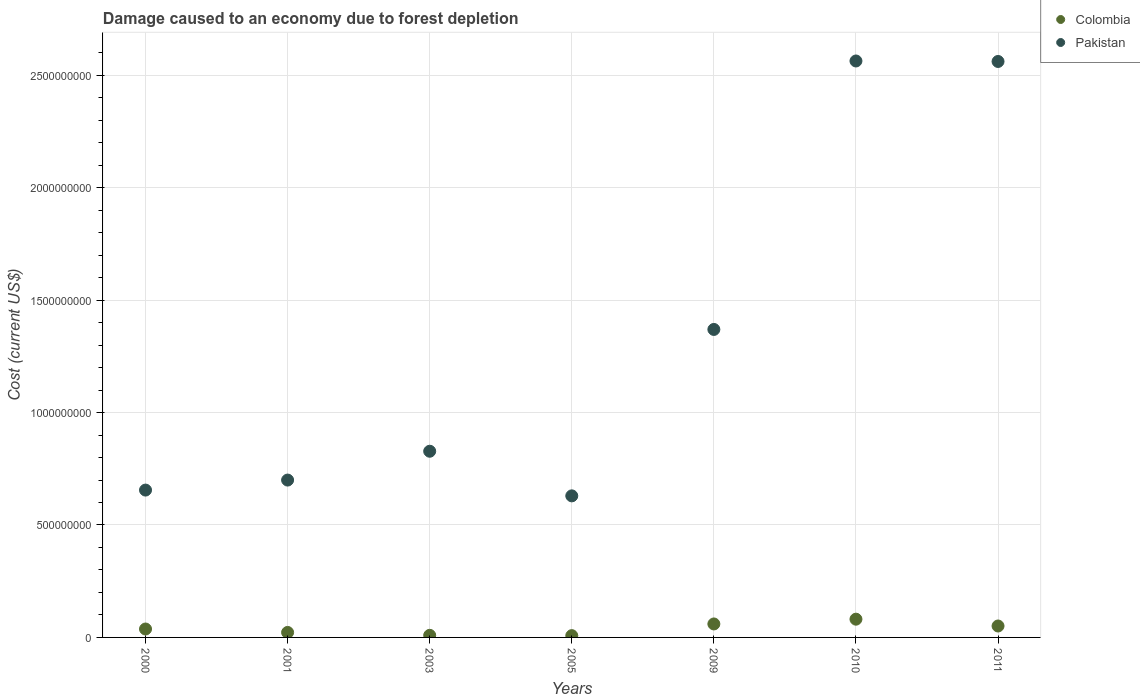What is the cost of damage caused due to forest depletion in Colombia in 2000?
Your answer should be very brief. 3.74e+07. Across all years, what is the maximum cost of damage caused due to forest depletion in Pakistan?
Give a very brief answer. 2.56e+09. Across all years, what is the minimum cost of damage caused due to forest depletion in Pakistan?
Provide a short and direct response. 6.30e+08. In which year was the cost of damage caused due to forest depletion in Pakistan minimum?
Give a very brief answer. 2005. What is the total cost of damage caused due to forest depletion in Colombia in the graph?
Provide a short and direct response. 2.69e+08. What is the difference between the cost of damage caused due to forest depletion in Pakistan in 2003 and that in 2010?
Make the answer very short. -1.74e+09. What is the difference between the cost of damage caused due to forest depletion in Colombia in 2003 and the cost of damage caused due to forest depletion in Pakistan in 2001?
Your answer should be compact. -6.91e+08. What is the average cost of damage caused due to forest depletion in Pakistan per year?
Offer a terse response. 1.33e+09. In the year 2003, what is the difference between the cost of damage caused due to forest depletion in Pakistan and cost of damage caused due to forest depletion in Colombia?
Keep it short and to the point. 8.19e+08. What is the ratio of the cost of damage caused due to forest depletion in Pakistan in 2001 to that in 2003?
Provide a succinct answer. 0.85. Is the cost of damage caused due to forest depletion in Pakistan in 2005 less than that in 2011?
Keep it short and to the point. Yes. What is the difference between the highest and the second highest cost of damage caused due to forest depletion in Colombia?
Keep it short and to the point. 2.12e+07. What is the difference between the highest and the lowest cost of damage caused due to forest depletion in Pakistan?
Give a very brief answer. 1.93e+09. Does the cost of damage caused due to forest depletion in Colombia monotonically increase over the years?
Offer a very short reply. No. Is the cost of damage caused due to forest depletion in Colombia strictly greater than the cost of damage caused due to forest depletion in Pakistan over the years?
Your answer should be very brief. No. Is the cost of damage caused due to forest depletion in Colombia strictly less than the cost of damage caused due to forest depletion in Pakistan over the years?
Your answer should be very brief. Yes. How many years are there in the graph?
Give a very brief answer. 7. What is the difference between two consecutive major ticks on the Y-axis?
Ensure brevity in your answer.  5.00e+08. Does the graph contain any zero values?
Provide a succinct answer. No. Does the graph contain grids?
Ensure brevity in your answer.  Yes. Where does the legend appear in the graph?
Your answer should be compact. Top right. How are the legend labels stacked?
Provide a succinct answer. Vertical. What is the title of the graph?
Offer a very short reply. Damage caused to an economy due to forest depletion. Does "Korea (Democratic)" appear as one of the legend labels in the graph?
Ensure brevity in your answer.  No. What is the label or title of the X-axis?
Provide a succinct answer. Years. What is the label or title of the Y-axis?
Your response must be concise. Cost (current US$). What is the Cost (current US$) in Colombia in 2000?
Provide a short and direct response. 3.74e+07. What is the Cost (current US$) in Pakistan in 2000?
Your response must be concise. 6.55e+08. What is the Cost (current US$) of Colombia in 2001?
Give a very brief answer. 2.22e+07. What is the Cost (current US$) of Pakistan in 2001?
Offer a very short reply. 7.00e+08. What is the Cost (current US$) in Colombia in 2003?
Give a very brief answer. 9.33e+06. What is the Cost (current US$) in Pakistan in 2003?
Your answer should be compact. 8.28e+08. What is the Cost (current US$) of Colombia in 2005?
Give a very brief answer. 7.93e+06. What is the Cost (current US$) in Pakistan in 2005?
Your answer should be very brief. 6.30e+08. What is the Cost (current US$) in Colombia in 2009?
Give a very brief answer. 5.99e+07. What is the Cost (current US$) in Pakistan in 2009?
Your answer should be compact. 1.37e+09. What is the Cost (current US$) of Colombia in 2010?
Offer a very short reply. 8.12e+07. What is the Cost (current US$) in Pakistan in 2010?
Provide a succinct answer. 2.56e+09. What is the Cost (current US$) of Colombia in 2011?
Offer a terse response. 5.09e+07. What is the Cost (current US$) of Pakistan in 2011?
Provide a succinct answer. 2.56e+09. Across all years, what is the maximum Cost (current US$) of Colombia?
Give a very brief answer. 8.12e+07. Across all years, what is the maximum Cost (current US$) of Pakistan?
Offer a very short reply. 2.56e+09. Across all years, what is the minimum Cost (current US$) in Colombia?
Offer a terse response. 7.93e+06. Across all years, what is the minimum Cost (current US$) in Pakistan?
Keep it short and to the point. 6.30e+08. What is the total Cost (current US$) of Colombia in the graph?
Give a very brief answer. 2.69e+08. What is the total Cost (current US$) in Pakistan in the graph?
Make the answer very short. 9.31e+09. What is the difference between the Cost (current US$) in Colombia in 2000 and that in 2001?
Provide a succinct answer. 1.52e+07. What is the difference between the Cost (current US$) in Pakistan in 2000 and that in 2001?
Ensure brevity in your answer.  -4.45e+07. What is the difference between the Cost (current US$) of Colombia in 2000 and that in 2003?
Your answer should be very brief. 2.81e+07. What is the difference between the Cost (current US$) in Pakistan in 2000 and that in 2003?
Provide a short and direct response. -1.73e+08. What is the difference between the Cost (current US$) in Colombia in 2000 and that in 2005?
Offer a terse response. 2.95e+07. What is the difference between the Cost (current US$) of Pakistan in 2000 and that in 2005?
Ensure brevity in your answer.  2.57e+07. What is the difference between the Cost (current US$) of Colombia in 2000 and that in 2009?
Make the answer very short. -2.25e+07. What is the difference between the Cost (current US$) in Pakistan in 2000 and that in 2009?
Make the answer very short. -7.14e+08. What is the difference between the Cost (current US$) in Colombia in 2000 and that in 2010?
Make the answer very short. -4.37e+07. What is the difference between the Cost (current US$) in Pakistan in 2000 and that in 2010?
Keep it short and to the point. -1.91e+09. What is the difference between the Cost (current US$) of Colombia in 2000 and that in 2011?
Your response must be concise. -1.34e+07. What is the difference between the Cost (current US$) in Pakistan in 2000 and that in 2011?
Ensure brevity in your answer.  -1.91e+09. What is the difference between the Cost (current US$) in Colombia in 2001 and that in 2003?
Your answer should be very brief. 1.29e+07. What is the difference between the Cost (current US$) of Pakistan in 2001 and that in 2003?
Your answer should be compact. -1.28e+08. What is the difference between the Cost (current US$) in Colombia in 2001 and that in 2005?
Give a very brief answer. 1.43e+07. What is the difference between the Cost (current US$) in Pakistan in 2001 and that in 2005?
Your answer should be compact. 7.03e+07. What is the difference between the Cost (current US$) in Colombia in 2001 and that in 2009?
Your answer should be compact. -3.77e+07. What is the difference between the Cost (current US$) of Pakistan in 2001 and that in 2009?
Your response must be concise. -6.70e+08. What is the difference between the Cost (current US$) in Colombia in 2001 and that in 2010?
Give a very brief answer. -5.89e+07. What is the difference between the Cost (current US$) in Pakistan in 2001 and that in 2010?
Keep it short and to the point. -1.86e+09. What is the difference between the Cost (current US$) in Colombia in 2001 and that in 2011?
Ensure brevity in your answer.  -2.86e+07. What is the difference between the Cost (current US$) in Pakistan in 2001 and that in 2011?
Make the answer very short. -1.86e+09. What is the difference between the Cost (current US$) in Colombia in 2003 and that in 2005?
Your response must be concise. 1.39e+06. What is the difference between the Cost (current US$) in Pakistan in 2003 and that in 2005?
Ensure brevity in your answer.  1.98e+08. What is the difference between the Cost (current US$) of Colombia in 2003 and that in 2009?
Give a very brief answer. -5.06e+07. What is the difference between the Cost (current US$) in Pakistan in 2003 and that in 2009?
Provide a short and direct response. -5.42e+08. What is the difference between the Cost (current US$) of Colombia in 2003 and that in 2010?
Provide a short and direct response. -7.18e+07. What is the difference between the Cost (current US$) in Pakistan in 2003 and that in 2010?
Your answer should be very brief. -1.74e+09. What is the difference between the Cost (current US$) in Colombia in 2003 and that in 2011?
Your answer should be very brief. -4.15e+07. What is the difference between the Cost (current US$) of Pakistan in 2003 and that in 2011?
Ensure brevity in your answer.  -1.73e+09. What is the difference between the Cost (current US$) of Colombia in 2005 and that in 2009?
Offer a very short reply. -5.20e+07. What is the difference between the Cost (current US$) of Pakistan in 2005 and that in 2009?
Provide a succinct answer. -7.40e+08. What is the difference between the Cost (current US$) of Colombia in 2005 and that in 2010?
Provide a short and direct response. -7.32e+07. What is the difference between the Cost (current US$) of Pakistan in 2005 and that in 2010?
Offer a very short reply. -1.93e+09. What is the difference between the Cost (current US$) of Colombia in 2005 and that in 2011?
Provide a short and direct response. -4.29e+07. What is the difference between the Cost (current US$) of Pakistan in 2005 and that in 2011?
Offer a very short reply. -1.93e+09. What is the difference between the Cost (current US$) of Colombia in 2009 and that in 2010?
Give a very brief answer. -2.12e+07. What is the difference between the Cost (current US$) of Pakistan in 2009 and that in 2010?
Give a very brief answer. -1.19e+09. What is the difference between the Cost (current US$) of Colombia in 2009 and that in 2011?
Offer a terse response. 9.06e+06. What is the difference between the Cost (current US$) in Pakistan in 2009 and that in 2011?
Offer a very short reply. -1.19e+09. What is the difference between the Cost (current US$) of Colombia in 2010 and that in 2011?
Make the answer very short. 3.03e+07. What is the difference between the Cost (current US$) in Pakistan in 2010 and that in 2011?
Keep it short and to the point. 2.16e+06. What is the difference between the Cost (current US$) in Colombia in 2000 and the Cost (current US$) in Pakistan in 2001?
Ensure brevity in your answer.  -6.62e+08. What is the difference between the Cost (current US$) of Colombia in 2000 and the Cost (current US$) of Pakistan in 2003?
Provide a succinct answer. -7.91e+08. What is the difference between the Cost (current US$) of Colombia in 2000 and the Cost (current US$) of Pakistan in 2005?
Provide a short and direct response. -5.92e+08. What is the difference between the Cost (current US$) of Colombia in 2000 and the Cost (current US$) of Pakistan in 2009?
Offer a very short reply. -1.33e+09. What is the difference between the Cost (current US$) in Colombia in 2000 and the Cost (current US$) in Pakistan in 2010?
Provide a short and direct response. -2.53e+09. What is the difference between the Cost (current US$) of Colombia in 2000 and the Cost (current US$) of Pakistan in 2011?
Keep it short and to the point. -2.52e+09. What is the difference between the Cost (current US$) in Colombia in 2001 and the Cost (current US$) in Pakistan in 2003?
Ensure brevity in your answer.  -8.06e+08. What is the difference between the Cost (current US$) of Colombia in 2001 and the Cost (current US$) of Pakistan in 2005?
Give a very brief answer. -6.07e+08. What is the difference between the Cost (current US$) of Colombia in 2001 and the Cost (current US$) of Pakistan in 2009?
Make the answer very short. -1.35e+09. What is the difference between the Cost (current US$) of Colombia in 2001 and the Cost (current US$) of Pakistan in 2010?
Give a very brief answer. -2.54e+09. What is the difference between the Cost (current US$) of Colombia in 2001 and the Cost (current US$) of Pakistan in 2011?
Keep it short and to the point. -2.54e+09. What is the difference between the Cost (current US$) of Colombia in 2003 and the Cost (current US$) of Pakistan in 2005?
Offer a very short reply. -6.20e+08. What is the difference between the Cost (current US$) of Colombia in 2003 and the Cost (current US$) of Pakistan in 2009?
Make the answer very short. -1.36e+09. What is the difference between the Cost (current US$) of Colombia in 2003 and the Cost (current US$) of Pakistan in 2010?
Ensure brevity in your answer.  -2.55e+09. What is the difference between the Cost (current US$) of Colombia in 2003 and the Cost (current US$) of Pakistan in 2011?
Provide a short and direct response. -2.55e+09. What is the difference between the Cost (current US$) in Colombia in 2005 and the Cost (current US$) in Pakistan in 2009?
Offer a terse response. -1.36e+09. What is the difference between the Cost (current US$) in Colombia in 2005 and the Cost (current US$) in Pakistan in 2010?
Your answer should be compact. -2.56e+09. What is the difference between the Cost (current US$) of Colombia in 2005 and the Cost (current US$) of Pakistan in 2011?
Provide a succinct answer. -2.55e+09. What is the difference between the Cost (current US$) of Colombia in 2009 and the Cost (current US$) of Pakistan in 2010?
Your answer should be compact. -2.50e+09. What is the difference between the Cost (current US$) in Colombia in 2009 and the Cost (current US$) in Pakistan in 2011?
Make the answer very short. -2.50e+09. What is the difference between the Cost (current US$) of Colombia in 2010 and the Cost (current US$) of Pakistan in 2011?
Give a very brief answer. -2.48e+09. What is the average Cost (current US$) of Colombia per year?
Offer a very short reply. 3.84e+07. What is the average Cost (current US$) in Pakistan per year?
Your answer should be very brief. 1.33e+09. In the year 2000, what is the difference between the Cost (current US$) of Colombia and Cost (current US$) of Pakistan?
Provide a short and direct response. -6.18e+08. In the year 2001, what is the difference between the Cost (current US$) in Colombia and Cost (current US$) in Pakistan?
Your response must be concise. -6.78e+08. In the year 2003, what is the difference between the Cost (current US$) of Colombia and Cost (current US$) of Pakistan?
Ensure brevity in your answer.  -8.19e+08. In the year 2005, what is the difference between the Cost (current US$) in Colombia and Cost (current US$) in Pakistan?
Your answer should be very brief. -6.22e+08. In the year 2009, what is the difference between the Cost (current US$) of Colombia and Cost (current US$) of Pakistan?
Ensure brevity in your answer.  -1.31e+09. In the year 2010, what is the difference between the Cost (current US$) of Colombia and Cost (current US$) of Pakistan?
Your answer should be compact. -2.48e+09. In the year 2011, what is the difference between the Cost (current US$) in Colombia and Cost (current US$) in Pakistan?
Your answer should be compact. -2.51e+09. What is the ratio of the Cost (current US$) in Colombia in 2000 to that in 2001?
Provide a short and direct response. 1.68. What is the ratio of the Cost (current US$) of Pakistan in 2000 to that in 2001?
Provide a short and direct response. 0.94. What is the ratio of the Cost (current US$) of Colombia in 2000 to that in 2003?
Your answer should be compact. 4.01. What is the ratio of the Cost (current US$) in Pakistan in 2000 to that in 2003?
Keep it short and to the point. 0.79. What is the ratio of the Cost (current US$) of Colombia in 2000 to that in 2005?
Keep it short and to the point. 4.71. What is the ratio of the Cost (current US$) in Pakistan in 2000 to that in 2005?
Make the answer very short. 1.04. What is the ratio of the Cost (current US$) of Colombia in 2000 to that in 2009?
Keep it short and to the point. 0.62. What is the ratio of the Cost (current US$) in Pakistan in 2000 to that in 2009?
Ensure brevity in your answer.  0.48. What is the ratio of the Cost (current US$) of Colombia in 2000 to that in 2010?
Provide a succinct answer. 0.46. What is the ratio of the Cost (current US$) of Pakistan in 2000 to that in 2010?
Keep it short and to the point. 0.26. What is the ratio of the Cost (current US$) in Colombia in 2000 to that in 2011?
Your response must be concise. 0.74. What is the ratio of the Cost (current US$) in Pakistan in 2000 to that in 2011?
Your response must be concise. 0.26. What is the ratio of the Cost (current US$) of Colombia in 2001 to that in 2003?
Your answer should be very brief. 2.38. What is the ratio of the Cost (current US$) of Pakistan in 2001 to that in 2003?
Provide a succinct answer. 0.85. What is the ratio of the Cost (current US$) of Colombia in 2001 to that in 2005?
Keep it short and to the point. 2.8. What is the ratio of the Cost (current US$) in Pakistan in 2001 to that in 2005?
Offer a terse response. 1.11. What is the ratio of the Cost (current US$) in Colombia in 2001 to that in 2009?
Offer a terse response. 0.37. What is the ratio of the Cost (current US$) of Pakistan in 2001 to that in 2009?
Provide a succinct answer. 0.51. What is the ratio of the Cost (current US$) of Colombia in 2001 to that in 2010?
Offer a terse response. 0.27. What is the ratio of the Cost (current US$) of Pakistan in 2001 to that in 2010?
Provide a succinct answer. 0.27. What is the ratio of the Cost (current US$) of Colombia in 2001 to that in 2011?
Your response must be concise. 0.44. What is the ratio of the Cost (current US$) of Pakistan in 2001 to that in 2011?
Keep it short and to the point. 0.27. What is the ratio of the Cost (current US$) of Colombia in 2003 to that in 2005?
Keep it short and to the point. 1.18. What is the ratio of the Cost (current US$) of Pakistan in 2003 to that in 2005?
Provide a succinct answer. 1.32. What is the ratio of the Cost (current US$) in Colombia in 2003 to that in 2009?
Offer a terse response. 0.16. What is the ratio of the Cost (current US$) in Pakistan in 2003 to that in 2009?
Offer a terse response. 0.6. What is the ratio of the Cost (current US$) of Colombia in 2003 to that in 2010?
Keep it short and to the point. 0.11. What is the ratio of the Cost (current US$) in Pakistan in 2003 to that in 2010?
Offer a terse response. 0.32. What is the ratio of the Cost (current US$) in Colombia in 2003 to that in 2011?
Provide a short and direct response. 0.18. What is the ratio of the Cost (current US$) of Pakistan in 2003 to that in 2011?
Provide a short and direct response. 0.32. What is the ratio of the Cost (current US$) in Colombia in 2005 to that in 2009?
Make the answer very short. 0.13. What is the ratio of the Cost (current US$) of Pakistan in 2005 to that in 2009?
Give a very brief answer. 0.46. What is the ratio of the Cost (current US$) of Colombia in 2005 to that in 2010?
Offer a terse response. 0.1. What is the ratio of the Cost (current US$) of Pakistan in 2005 to that in 2010?
Provide a short and direct response. 0.25. What is the ratio of the Cost (current US$) in Colombia in 2005 to that in 2011?
Ensure brevity in your answer.  0.16. What is the ratio of the Cost (current US$) of Pakistan in 2005 to that in 2011?
Provide a short and direct response. 0.25. What is the ratio of the Cost (current US$) of Colombia in 2009 to that in 2010?
Give a very brief answer. 0.74. What is the ratio of the Cost (current US$) in Pakistan in 2009 to that in 2010?
Provide a short and direct response. 0.53. What is the ratio of the Cost (current US$) in Colombia in 2009 to that in 2011?
Offer a terse response. 1.18. What is the ratio of the Cost (current US$) of Pakistan in 2009 to that in 2011?
Provide a succinct answer. 0.53. What is the ratio of the Cost (current US$) of Colombia in 2010 to that in 2011?
Make the answer very short. 1.6. What is the ratio of the Cost (current US$) in Pakistan in 2010 to that in 2011?
Offer a terse response. 1. What is the difference between the highest and the second highest Cost (current US$) of Colombia?
Give a very brief answer. 2.12e+07. What is the difference between the highest and the second highest Cost (current US$) of Pakistan?
Provide a short and direct response. 2.16e+06. What is the difference between the highest and the lowest Cost (current US$) of Colombia?
Provide a short and direct response. 7.32e+07. What is the difference between the highest and the lowest Cost (current US$) in Pakistan?
Offer a very short reply. 1.93e+09. 